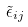Convert formula to latex. <formula><loc_0><loc_0><loc_500><loc_500>\tilde { \epsilon } _ { i j }</formula> 